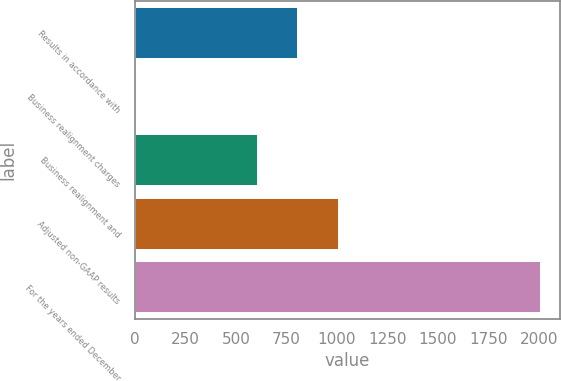Convert chart to OTSL. <chart><loc_0><loc_0><loc_500><loc_500><bar_chart><fcel>Results in accordance with<fcel>Business realignment charges<fcel>Business realignment and<fcel>Adjusted non-GAAP results<fcel>For the years ended December<nl><fcel>803.52<fcel>3.2<fcel>603.44<fcel>1003.6<fcel>2004<nl></chart> 